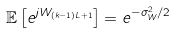Convert formula to latex. <formula><loc_0><loc_0><loc_500><loc_500>\mathbb { E } \left [ e ^ { j W _ { ( k - 1 ) L + 1 } } \right ] = e ^ { - \sigma ^ { 2 } _ { W } / 2 }</formula> 